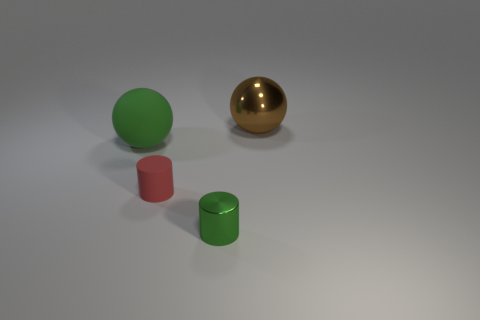What is the big green object made of?
Your response must be concise. Rubber. There is a metal thing that is in front of the big metallic object; is it the same shape as the large green thing?
Provide a short and direct response. No. The ball that is the same color as the tiny shiny object is what size?
Your response must be concise. Large. Is there a green metallic object that has the same size as the green rubber sphere?
Your answer should be compact. No. There is a big object that is in front of the big thing on the right side of the large green matte thing; are there any green metallic objects left of it?
Your answer should be compact. No. There is a tiny metallic cylinder; is it the same color as the ball on the left side of the metallic ball?
Make the answer very short. Yes. There is a big object in front of the big ball that is behind the large object to the left of the brown shiny ball; what is its material?
Your answer should be compact. Rubber. There is a thing behind the large green thing; what shape is it?
Provide a short and direct response. Sphere. There is a green thing that is the same material as the tiny red cylinder; what is its size?
Offer a very short reply. Large. How many brown objects are the same shape as the green rubber object?
Keep it short and to the point. 1. 